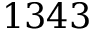Convert formula to latex. <formula><loc_0><loc_0><loc_500><loc_500>1 3 4 3</formula> 